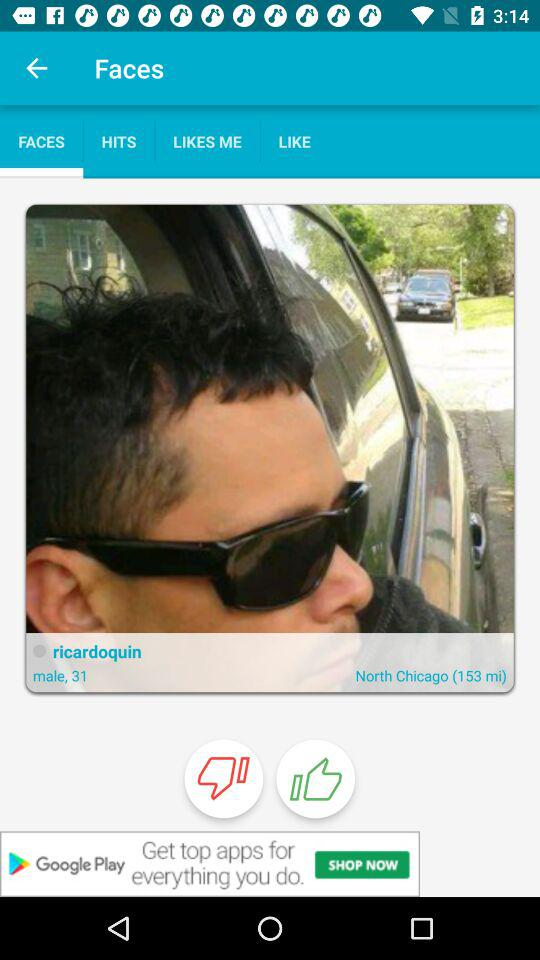Which tab am I on? You are on the "FACES" tab. 